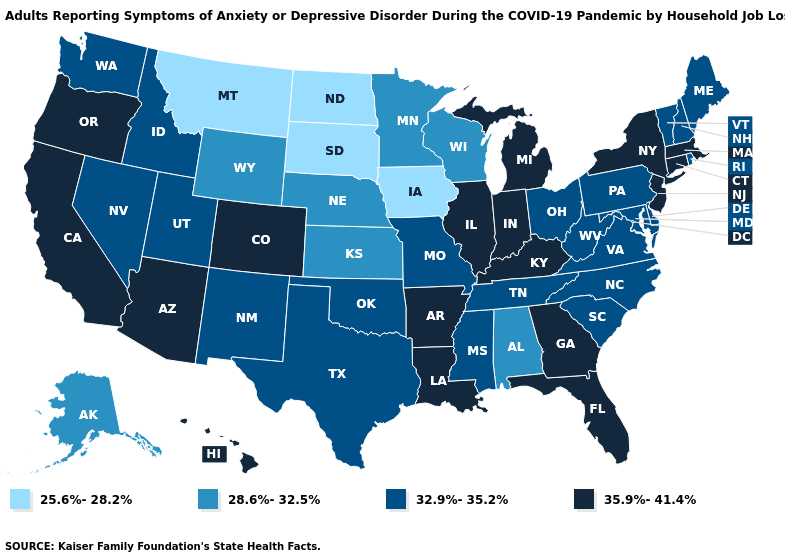Does Washington have the same value as Virginia?
Concise answer only. Yes. Does Louisiana have a higher value than Mississippi?
Short answer required. Yes. What is the value of Illinois?
Concise answer only. 35.9%-41.4%. Does the map have missing data?
Keep it brief. No. Name the states that have a value in the range 32.9%-35.2%?
Short answer required. Delaware, Idaho, Maine, Maryland, Mississippi, Missouri, Nevada, New Hampshire, New Mexico, North Carolina, Ohio, Oklahoma, Pennsylvania, Rhode Island, South Carolina, Tennessee, Texas, Utah, Vermont, Virginia, Washington, West Virginia. What is the highest value in states that border Delaware?
Give a very brief answer. 35.9%-41.4%. Name the states that have a value in the range 28.6%-32.5%?
Be succinct. Alabama, Alaska, Kansas, Minnesota, Nebraska, Wisconsin, Wyoming. Does Nevada have a lower value than Illinois?
Short answer required. Yes. Name the states that have a value in the range 32.9%-35.2%?
Write a very short answer. Delaware, Idaho, Maine, Maryland, Mississippi, Missouri, Nevada, New Hampshire, New Mexico, North Carolina, Ohio, Oklahoma, Pennsylvania, Rhode Island, South Carolina, Tennessee, Texas, Utah, Vermont, Virginia, Washington, West Virginia. Which states have the highest value in the USA?
Keep it brief. Arizona, Arkansas, California, Colorado, Connecticut, Florida, Georgia, Hawaii, Illinois, Indiana, Kentucky, Louisiana, Massachusetts, Michigan, New Jersey, New York, Oregon. What is the value of Louisiana?
Concise answer only. 35.9%-41.4%. What is the value of Michigan?
Be succinct. 35.9%-41.4%. What is the highest value in states that border Massachusetts?
Quick response, please. 35.9%-41.4%. Does the map have missing data?
Write a very short answer. No. What is the value of Arkansas?
Short answer required. 35.9%-41.4%. 